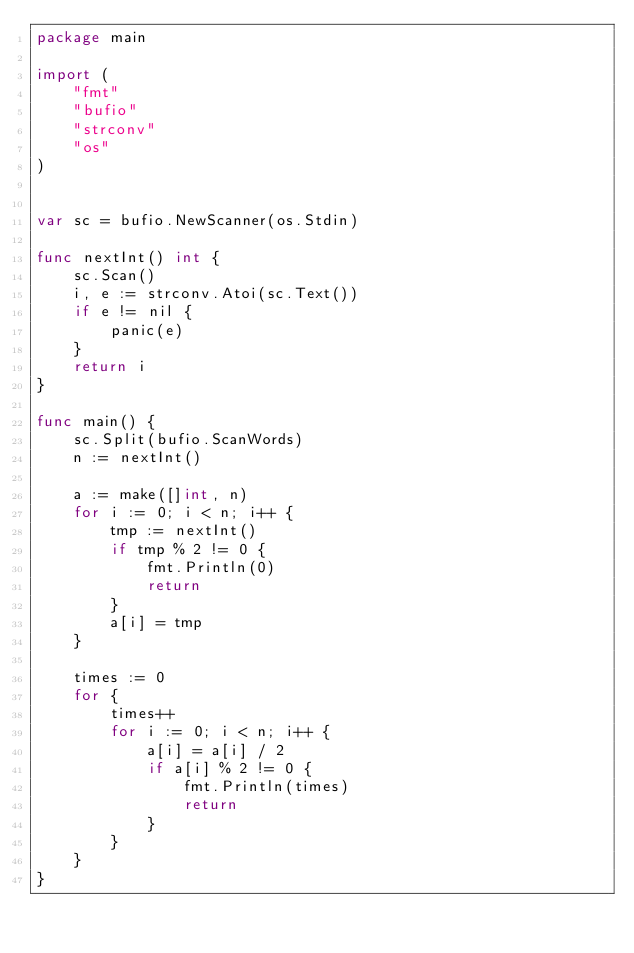Convert code to text. <code><loc_0><loc_0><loc_500><loc_500><_Go_>package main

import (
    "fmt"
    "bufio"
    "strconv"
    "os"
)


var sc = bufio.NewScanner(os.Stdin)

func nextInt() int {
    sc.Scan()
    i, e := strconv.Atoi(sc.Text())
    if e != nil {
        panic(e)
    }
    return i
}

func main() {
    sc.Split(bufio.ScanWords)
    n := nextInt()

    a := make([]int, n)
    for i := 0; i < n; i++ {
        tmp := nextInt()
        if tmp % 2 != 0 {
            fmt.Println(0)
            return
        }
        a[i] = tmp
    }

    times := 0
    for {
        times++
        for i := 0; i < n; i++ {
            a[i] = a[i] / 2
            if a[i] % 2 != 0 {
                fmt.Println(times)
                return
            }
        }
    }
}</code> 